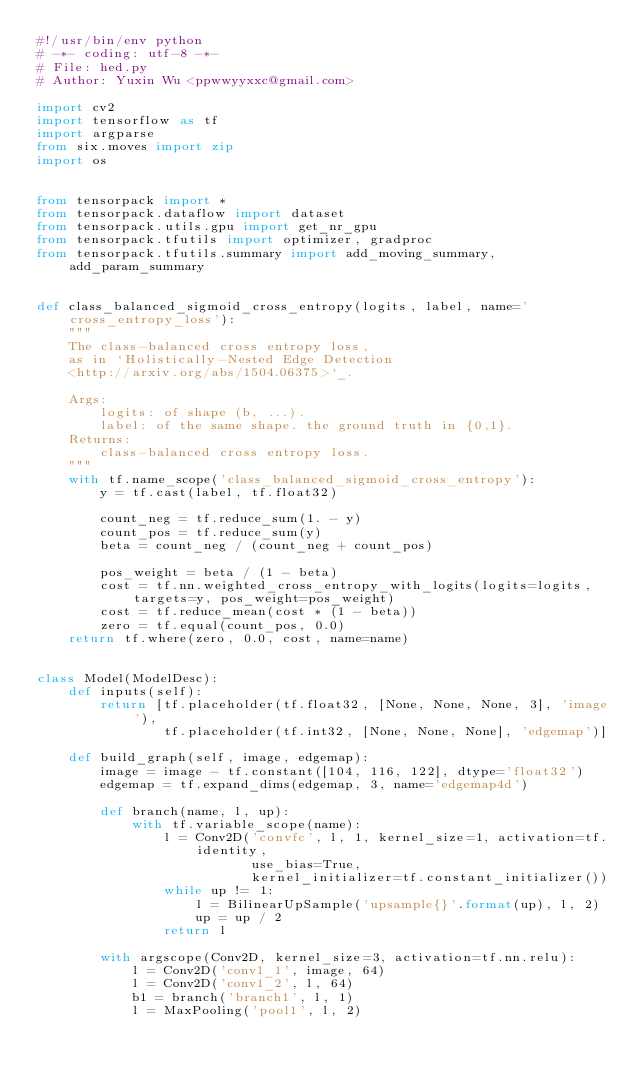Convert code to text. <code><loc_0><loc_0><loc_500><loc_500><_Python_>#!/usr/bin/env python
# -*- coding: utf-8 -*-
# File: hed.py
# Author: Yuxin Wu <ppwwyyxxc@gmail.com>

import cv2
import tensorflow as tf
import argparse
from six.moves import zip
import os


from tensorpack import *
from tensorpack.dataflow import dataset
from tensorpack.utils.gpu import get_nr_gpu
from tensorpack.tfutils import optimizer, gradproc
from tensorpack.tfutils.summary import add_moving_summary, add_param_summary


def class_balanced_sigmoid_cross_entropy(logits, label, name='cross_entropy_loss'):
    """
    The class-balanced cross entropy loss,
    as in `Holistically-Nested Edge Detection
    <http://arxiv.org/abs/1504.06375>`_.

    Args:
        logits: of shape (b, ...).
        label: of the same shape. the ground truth in {0,1}.
    Returns:
        class-balanced cross entropy loss.
    """
    with tf.name_scope('class_balanced_sigmoid_cross_entropy'):
        y = tf.cast(label, tf.float32)

        count_neg = tf.reduce_sum(1. - y)
        count_pos = tf.reduce_sum(y)
        beta = count_neg / (count_neg + count_pos)

        pos_weight = beta / (1 - beta)
        cost = tf.nn.weighted_cross_entropy_with_logits(logits=logits, targets=y, pos_weight=pos_weight)
        cost = tf.reduce_mean(cost * (1 - beta))
        zero = tf.equal(count_pos, 0.0)
    return tf.where(zero, 0.0, cost, name=name)


class Model(ModelDesc):
    def inputs(self):
        return [tf.placeholder(tf.float32, [None, None, None, 3], 'image'),
                tf.placeholder(tf.int32, [None, None, None], 'edgemap')]

    def build_graph(self, image, edgemap):
        image = image - tf.constant([104, 116, 122], dtype='float32')
        edgemap = tf.expand_dims(edgemap, 3, name='edgemap4d')

        def branch(name, l, up):
            with tf.variable_scope(name):
                l = Conv2D('convfc', l, 1, kernel_size=1, activation=tf.identity,
                           use_bias=True,
                           kernel_initializer=tf.constant_initializer())
                while up != 1:
                    l = BilinearUpSample('upsample{}'.format(up), l, 2)
                    up = up / 2
                return l

        with argscope(Conv2D, kernel_size=3, activation=tf.nn.relu):
            l = Conv2D('conv1_1', image, 64)
            l = Conv2D('conv1_2', l, 64)
            b1 = branch('branch1', l, 1)
            l = MaxPooling('pool1', l, 2)
</code> 